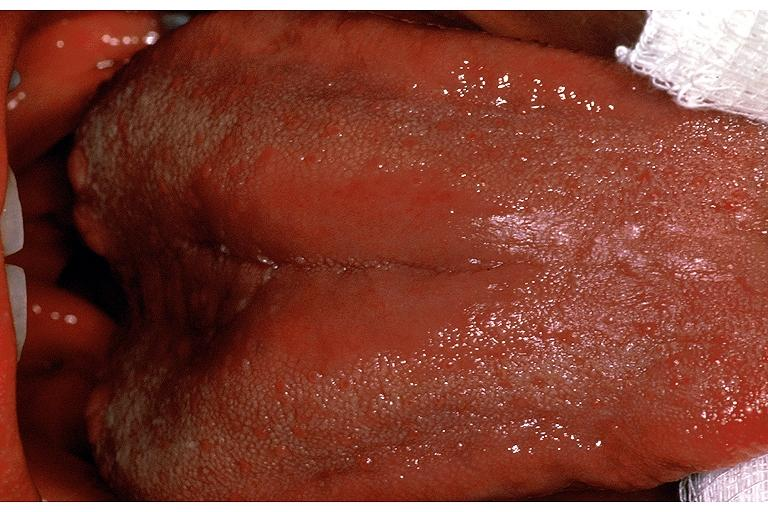s section of spleen through hilum present?
Answer the question using a single word or phrase. No 